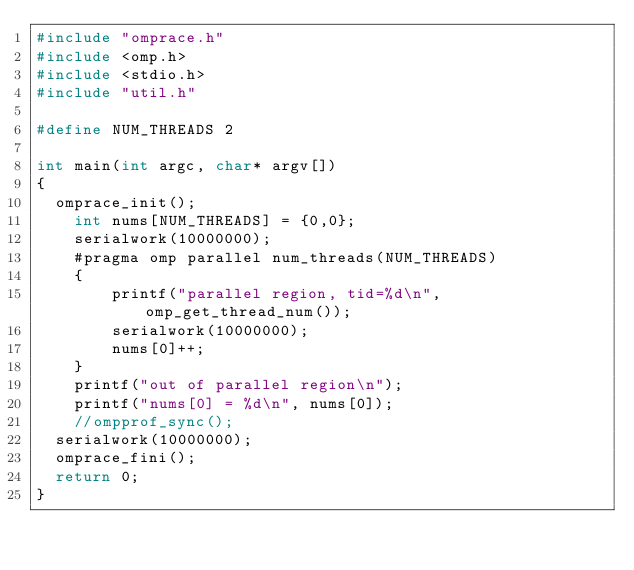<code> <loc_0><loc_0><loc_500><loc_500><_C++_>#include "omprace.h"
#include <omp.h>
#include <stdio.h>
#include "util.h"

#define NUM_THREADS 2

int main(int argc, char* argv[])
{
  omprace_init();
    int nums[NUM_THREADS] = {0,0};
    serialwork(10000000);
    #pragma omp parallel num_threads(NUM_THREADS)
    {
        printf("parallel region, tid=%d\n", omp_get_thread_num());
        serialwork(10000000);
	      nums[0]++;
    }
    printf("out of parallel region\n");
    printf("nums[0] = %d\n", nums[0]);
    //ompprof_sync();
  serialwork(10000000);
  omprace_fini();
  return 0;
}
</code> 